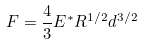<formula> <loc_0><loc_0><loc_500><loc_500>F = \frac { 4 } { 3 } E ^ { * } R ^ { 1 / 2 } d ^ { 3 / 2 }</formula> 